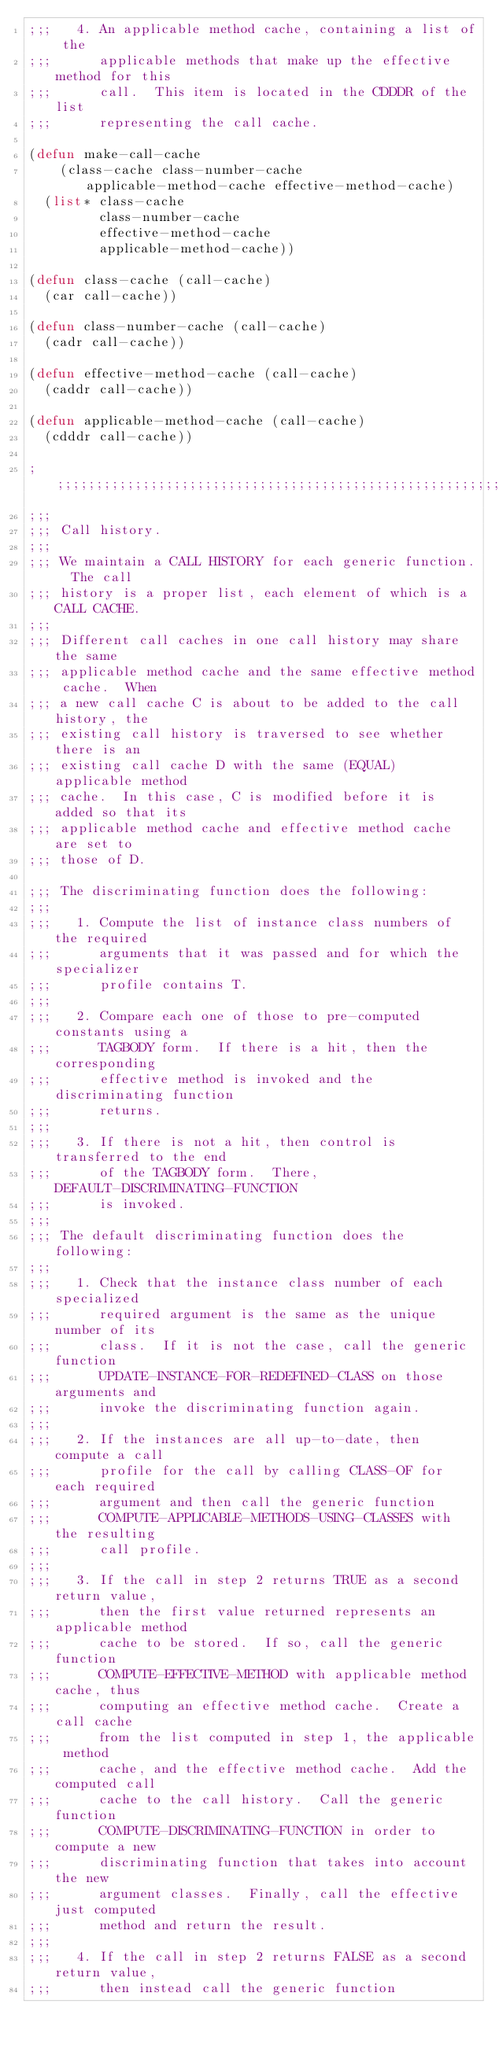Convert code to text. <code><loc_0><loc_0><loc_500><loc_500><_Lisp_>;;;   4. An applicable method cache, containing a list of the
;;;      applicable methods that make up the effective method for this
;;;      call.  This item is located in the CDDDR of the list
;;;      representing the call cache.

(defun make-call-cache
    (class-cache class-number-cache applicable-method-cache effective-method-cache)
  (list* class-cache
         class-number-cache
         effective-method-cache
         applicable-method-cache))

(defun class-cache (call-cache)
  (car call-cache))

(defun class-number-cache (call-cache)
  (cadr call-cache))

(defun effective-method-cache (call-cache)
  (caddr call-cache))

(defun applicable-method-cache (call-cache)
  (cdddr call-cache))

;;;;;;;;;;;;;;;;;;;;;;;;;;;;;;;;;;;;;;;;;;;;;;;;;;;;;;;;;;;;;;;;;;;;;;
;;;
;;; Call history.
;;;
;;; We maintain a CALL HISTORY for each generic function.  The call
;;; history is a proper list, each element of which is a CALL CACHE.
;;;
;;; Different call caches in one call history may share the same
;;; applicable method cache and the same effective method cache.  When
;;; a new call cache C is about to be added to the call history, the
;;; existing call history is traversed to see whether there is an
;;; existing call cache D with the same (EQUAL) applicable method
;;; cache.  In this case, C is modified before it is added so that its
;;; applicable method cache and effective method cache are set to
;;; those of D.

;;; The discriminating function does the following:
;;;
;;;   1. Compute the list of instance class numbers of the required
;;;      arguments that it was passed and for which the specializer
;;;      profile contains T.
;;;
;;;   2. Compare each one of those to pre-computed constants using a
;;;      TAGBODY form.  If there is a hit, then the corresponding
;;;      effective method is invoked and the discriminating function
;;;      returns.
;;;
;;;   3. If there is not a hit, then control is transferred to the end
;;;      of the TAGBODY form.  There, DEFAULT-DISCRIMINATING-FUNCTION
;;;      is invoked.
;;;
;;; The default discriminating function does the following:
;;;
;;;   1. Check that the instance class number of each specialized
;;;      required argument is the same as the unique number of its
;;;      class.  If it is not the case, call the generic function
;;;      UPDATE-INSTANCE-FOR-REDEFINED-CLASS on those arguments and
;;;      invoke the discriminating function again.
;;;
;;;   2. If the instances are all up-to-date, then compute a call
;;;      profile for the call by calling CLASS-OF for each required
;;;      argument and then call the generic function
;;;      COMPUTE-APPLICABLE-METHODS-USING-CLASSES with the resulting
;;;      call profile.
;;;
;;;   3. If the call in step 2 returns TRUE as a second return value,
;;;      then the first value returned represents an applicable method
;;;      cache to be stored.  If so, call the generic function
;;;      COMPUTE-EFFECTIVE-METHOD with applicable method cache, thus
;;;      computing an effective method cache.  Create a call cache
;;;      from the list computed in step 1, the applicable method
;;;      cache, and the effective method cache.  Add the computed call
;;;      cache to the call history.  Call the generic function
;;;      COMPUTE-DISCRIMINATING-FUNCTION in order to compute a new
;;;      discriminating function that takes into account the new
;;;      argument classes.  Finally, call the effective just computed
;;;      method and return the result.
;;;
;;;   4. If the call in step 2 returns FALSE as a second return value,
;;;      then instead call the generic function</code> 